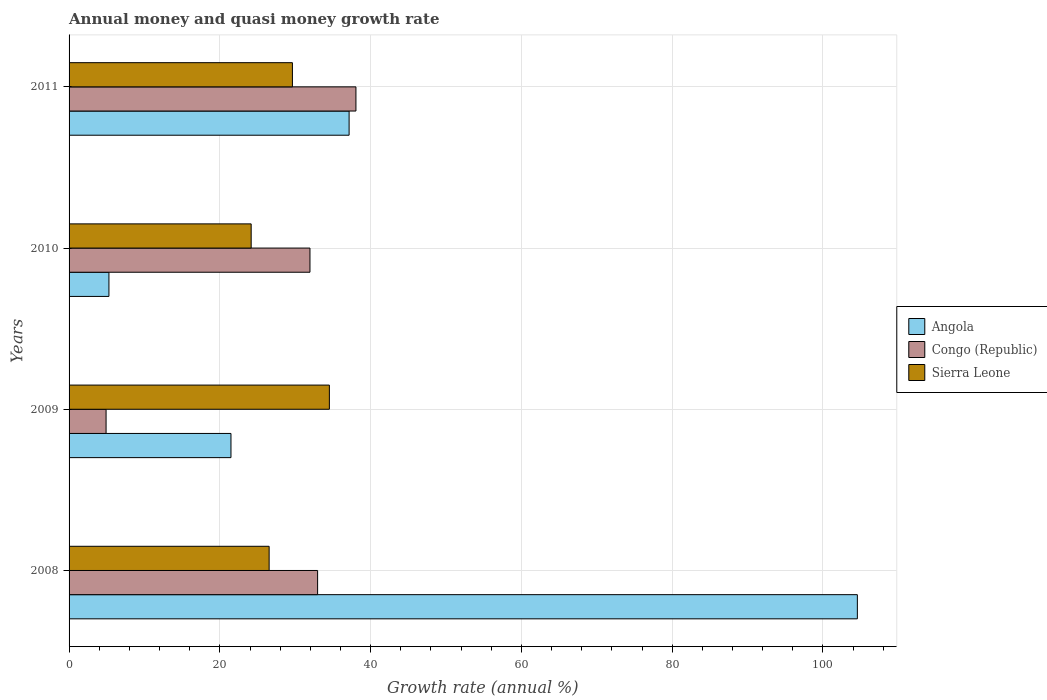Are the number of bars per tick equal to the number of legend labels?
Provide a short and direct response. Yes. How many bars are there on the 4th tick from the top?
Keep it short and to the point. 3. What is the growth rate in Angola in 2008?
Offer a terse response. 104.57. Across all years, what is the maximum growth rate in Congo (Republic)?
Your response must be concise. 38.05. Across all years, what is the minimum growth rate in Congo (Republic)?
Provide a short and direct response. 4.91. What is the total growth rate in Congo (Republic) in the graph?
Make the answer very short. 107.89. What is the difference between the growth rate in Angola in 2008 and that in 2010?
Offer a terse response. 99.28. What is the difference between the growth rate in Angola in 2010 and the growth rate in Sierra Leone in 2009?
Make the answer very short. -29.24. What is the average growth rate in Congo (Republic) per year?
Ensure brevity in your answer.  26.97. In the year 2009, what is the difference between the growth rate in Congo (Republic) and growth rate in Sierra Leone?
Keep it short and to the point. -29.62. In how many years, is the growth rate in Congo (Republic) greater than 72 %?
Offer a very short reply. 0. What is the ratio of the growth rate in Angola in 2010 to that in 2011?
Your answer should be compact. 0.14. Is the growth rate in Congo (Republic) in 2009 less than that in 2011?
Your response must be concise. Yes. What is the difference between the highest and the second highest growth rate in Congo (Republic)?
Offer a very short reply. 5.08. What is the difference between the highest and the lowest growth rate in Angola?
Your response must be concise. 99.28. In how many years, is the growth rate in Congo (Republic) greater than the average growth rate in Congo (Republic) taken over all years?
Offer a terse response. 3. What does the 3rd bar from the top in 2009 represents?
Keep it short and to the point. Angola. What does the 3rd bar from the bottom in 2011 represents?
Ensure brevity in your answer.  Sierra Leone. Is it the case that in every year, the sum of the growth rate in Congo (Republic) and growth rate in Sierra Leone is greater than the growth rate in Angola?
Keep it short and to the point. No. Are all the bars in the graph horizontal?
Keep it short and to the point. Yes. How many years are there in the graph?
Your answer should be very brief. 4. What is the difference between two consecutive major ticks on the X-axis?
Your response must be concise. 20. Are the values on the major ticks of X-axis written in scientific E-notation?
Provide a short and direct response. No. Does the graph contain any zero values?
Offer a terse response. No. Does the graph contain grids?
Offer a very short reply. Yes. Where does the legend appear in the graph?
Give a very brief answer. Center right. How many legend labels are there?
Offer a very short reply. 3. What is the title of the graph?
Your response must be concise. Annual money and quasi money growth rate. Does "Iran" appear as one of the legend labels in the graph?
Offer a terse response. No. What is the label or title of the X-axis?
Your answer should be compact. Growth rate (annual %). What is the label or title of the Y-axis?
Provide a succinct answer. Years. What is the Growth rate (annual %) of Angola in 2008?
Make the answer very short. 104.57. What is the Growth rate (annual %) in Congo (Republic) in 2008?
Your answer should be very brief. 32.97. What is the Growth rate (annual %) in Sierra Leone in 2008?
Your answer should be very brief. 26.54. What is the Growth rate (annual %) of Angola in 2009?
Offer a very short reply. 21.48. What is the Growth rate (annual %) of Congo (Republic) in 2009?
Provide a short and direct response. 4.91. What is the Growth rate (annual %) in Sierra Leone in 2009?
Provide a short and direct response. 34.53. What is the Growth rate (annual %) of Angola in 2010?
Your answer should be compact. 5.29. What is the Growth rate (annual %) in Congo (Republic) in 2010?
Give a very brief answer. 31.96. What is the Growth rate (annual %) in Sierra Leone in 2010?
Ensure brevity in your answer.  24.15. What is the Growth rate (annual %) of Angola in 2011?
Provide a succinct answer. 37.15. What is the Growth rate (annual %) in Congo (Republic) in 2011?
Ensure brevity in your answer.  38.05. What is the Growth rate (annual %) of Sierra Leone in 2011?
Give a very brief answer. 29.63. Across all years, what is the maximum Growth rate (annual %) of Angola?
Give a very brief answer. 104.57. Across all years, what is the maximum Growth rate (annual %) in Congo (Republic)?
Make the answer very short. 38.05. Across all years, what is the maximum Growth rate (annual %) in Sierra Leone?
Your answer should be compact. 34.53. Across all years, what is the minimum Growth rate (annual %) of Angola?
Provide a short and direct response. 5.29. Across all years, what is the minimum Growth rate (annual %) of Congo (Republic)?
Offer a terse response. 4.91. Across all years, what is the minimum Growth rate (annual %) of Sierra Leone?
Your answer should be compact. 24.15. What is the total Growth rate (annual %) in Angola in the graph?
Your answer should be very brief. 168.48. What is the total Growth rate (annual %) in Congo (Republic) in the graph?
Ensure brevity in your answer.  107.89. What is the total Growth rate (annual %) in Sierra Leone in the graph?
Provide a short and direct response. 114.85. What is the difference between the Growth rate (annual %) in Angola in 2008 and that in 2009?
Provide a succinct answer. 83.09. What is the difference between the Growth rate (annual %) of Congo (Republic) in 2008 and that in 2009?
Keep it short and to the point. 28.06. What is the difference between the Growth rate (annual %) of Sierra Leone in 2008 and that in 2009?
Give a very brief answer. -7.99. What is the difference between the Growth rate (annual %) of Angola in 2008 and that in 2010?
Your answer should be compact. 99.28. What is the difference between the Growth rate (annual %) of Congo (Republic) in 2008 and that in 2010?
Provide a succinct answer. 1.01. What is the difference between the Growth rate (annual %) of Sierra Leone in 2008 and that in 2010?
Offer a terse response. 2.38. What is the difference between the Growth rate (annual %) of Angola in 2008 and that in 2011?
Offer a very short reply. 67.42. What is the difference between the Growth rate (annual %) of Congo (Republic) in 2008 and that in 2011?
Provide a short and direct response. -5.08. What is the difference between the Growth rate (annual %) of Sierra Leone in 2008 and that in 2011?
Ensure brevity in your answer.  -3.09. What is the difference between the Growth rate (annual %) of Angola in 2009 and that in 2010?
Offer a very short reply. 16.19. What is the difference between the Growth rate (annual %) of Congo (Republic) in 2009 and that in 2010?
Your response must be concise. -27.05. What is the difference between the Growth rate (annual %) of Sierra Leone in 2009 and that in 2010?
Give a very brief answer. 10.37. What is the difference between the Growth rate (annual %) of Angola in 2009 and that in 2011?
Your answer should be compact. -15.67. What is the difference between the Growth rate (annual %) of Congo (Republic) in 2009 and that in 2011?
Give a very brief answer. -33.14. What is the difference between the Growth rate (annual %) of Sierra Leone in 2009 and that in 2011?
Your answer should be very brief. 4.9. What is the difference between the Growth rate (annual %) in Angola in 2010 and that in 2011?
Ensure brevity in your answer.  -31.86. What is the difference between the Growth rate (annual %) in Congo (Republic) in 2010 and that in 2011?
Your response must be concise. -6.1. What is the difference between the Growth rate (annual %) in Sierra Leone in 2010 and that in 2011?
Make the answer very short. -5.47. What is the difference between the Growth rate (annual %) in Angola in 2008 and the Growth rate (annual %) in Congo (Republic) in 2009?
Give a very brief answer. 99.66. What is the difference between the Growth rate (annual %) in Angola in 2008 and the Growth rate (annual %) in Sierra Leone in 2009?
Make the answer very short. 70.04. What is the difference between the Growth rate (annual %) of Congo (Republic) in 2008 and the Growth rate (annual %) of Sierra Leone in 2009?
Give a very brief answer. -1.56. What is the difference between the Growth rate (annual %) of Angola in 2008 and the Growth rate (annual %) of Congo (Republic) in 2010?
Your response must be concise. 72.61. What is the difference between the Growth rate (annual %) in Angola in 2008 and the Growth rate (annual %) in Sierra Leone in 2010?
Ensure brevity in your answer.  80.41. What is the difference between the Growth rate (annual %) in Congo (Republic) in 2008 and the Growth rate (annual %) in Sierra Leone in 2010?
Your answer should be very brief. 8.81. What is the difference between the Growth rate (annual %) in Angola in 2008 and the Growth rate (annual %) in Congo (Republic) in 2011?
Your response must be concise. 66.51. What is the difference between the Growth rate (annual %) of Angola in 2008 and the Growth rate (annual %) of Sierra Leone in 2011?
Provide a short and direct response. 74.94. What is the difference between the Growth rate (annual %) in Congo (Republic) in 2008 and the Growth rate (annual %) in Sierra Leone in 2011?
Provide a short and direct response. 3.34. What is the difference between the Growth rate (annual %) of Angola in 2009 and the Growth rate (annual %) of Congo (Republic) in 2010?
Ensure brevity in your answer.  -10.48. What is the difference between the Growth rate (annual %) of Angola in 2009 and the Growth rate (annual %) of Sierra Leone in 2010?
Keep it short and to the point. -2.68. What is the difference between the Growth rate (annual %) of Congo (Republic) in 2009 and the Growth rate (annual %) of Sierra Leone in 2010?
Offer a very short reply. -19.25. What is the difference between the Growth rate (annual %) of Angola in 2009 and the Growth rate (annual %) of Congo (Republic) in 2011?
Make the answer very short. -16.58. What is the difference between the Growth rate (annual %) in Angola in 2009 and the Growth rate (annual %) in Sierra Leone in 2011?
Provide a short and direct response. -8.15. What is the difference between the Growth rate (annual %) of Congo (Republic) in 2009 and the Growth rate (annual %) of Sierra Leone in 2011?
Offer a terse response. -24.72. What is the difference between the Growth rate (annual %) of Angola in 2010 and the Growth rate (annual %) of Congo (Republic) in 2011?
Provide a succinct answer. -32.76. What is the difference between the Growth rate (annual %) in Angola in 2010 and the Growth rate (annual %) in Sierra Leone in 2011?
Your answer should be very brief. -24.34. What is the difference between the Growth rate (annual %) in Congo (Republic) in 2010 and the Growth rate (annual %) in Sierra Leone in 2011?
Make the answer very short. 2.33. What is the average Growth rate (annual %) in Angola per year?
Offer a terse response. 42.12. What is the average Growth rate (annual %) of Congo (Republic) per year?
Make the answer very short. 26.97. What is the average Growth rate (annual %) in Sierra Leone per year?
Provide a short and direct response. 28.71. In the year 2008, what is the difference between the Growth rate (annual %) of Angola and Growth rate (annual %) of Congo (Republic)?
Offer a very short reply. 71.6. In the year 2008, what is the difference between the Growth rate (annual %) of Angola and Growth rate (annual %) of Sierra Leone?
Give a very brief answer. 78.03. In the year 2008, what is the difference between the Growth rate (annual %) of Congo (Republic) and Growth rate (annual %) of Sierra Leone?
Offer a very short reply. 6.43. In the year 2009, what is the difference between the Growth rate (annual %) of Angola and Growth rate (annual %) of Congo (Republic)?
Make the answer very short. 16.57. In the year 2009, what is the difference between the Growth rate (annual %) in Angola and Growth rate (annual %) in Sierra Leone?
Provide a succinct answer. -13.05. In the year 2009, what is the difference between the Growth rate (annual %) in Congo (Republic) and Growth rate (annual %) in Sierra Leone?
Provide a succinct answer. -29.62. In the year 2010, what is the difference between the Growth rate (annual %) in Angola and Growth rate (annual %) in Congo (Republic)?
Make the answer very short. -26.67. In the year 2010, what is the difference between the Growth rate (annual %) of Angola and Growth rate (annual %) of Sierra Leone?
Make the answer very short. -18.87. In the year 2010, what is the difference between the Growth rate (annual %) in Congo (Republic) and Growth rate (annual %) in Sierra Leone?
Your answer should be very brief. 7.8. In the year 2011, what is the difference between the Growth rate (annual %) in Angola and Growth rate (annual %) in Congo (Republic)?
Give a very brief answer. -0.91. In the year 2011, what is the difference between the Growth rate (annual %) of Angola and Growth rate (annual %) of Sierra Leone?
Your answer should be compact. 7.52. In the year 2011, what is the difference between the Growth rate (annual %) of Congo (Republic) and Growth rate (annual %) of Sierra Leone?
Give a very brief answer. 8.42. What is the ratio of the Growth rate (annual %) in Angola in 2008 to that in 2009?
Your answer should be compact. 4.87. What is the ratio of the Growth rate (annual %) of Congo (Republic) in 2008 to that in 2009?
Offer a terse response. 6.72. What is the ratio of the Growth rate (annual %) in Sierra Leone in 2008 to that in 2009?
Your answer should be compact. 0.77. What is the ratio of the Growth rate (annual %) in Angola in 2008 to that in 2010?
Your answer should be very brief. 19.77. What is the ratio of the Growth rate (annual %) of Congo (Republic) in 2008 to that in 2010?
Offer a terse response. 1.03. What is the ratio of the Growth rate (annual %) of Sierra Leone in 2008 to that in 2010?
Make the answer very short. 1.1. What is the ratio of the Growth rate (annual %) in Angola in 2008 to that in 2011?
Provide a short and direct response. 2.81. What is the ratio of the Growth rate (annual %) of Congo (Republic) in 2008 to that in 2011?
Provide a succinct answer. 0.87. What is the ratio of the Growth rate (annual %) of Sierra Leone in 2008 to that in 2011?
Provide a short and direct response. 0.9. What is the ratio of the Growth rate (annual %) of Angola in 2009 to that in 2010?
Your response must be concise. 4.06. What is the ratio of the Growth rate (annual %) of Congo (Republic) in 2009 to that in 2010?
Offer a very short reply. 0.15. What is the ratio of the Growth rate (annual %) of Sierra Leone in 2009 to that in 2010?
Provide a short and direct response. 1.43. What is the ratio of the Growth rate (annual %) of Angola in 2009 to that in 2011?
Give a very brief answer. 0.58. What is the ratio of the Growth rate (annual %) in Congo (Republic) in 2009 to that in 2011?
Keep it short and to the point. 0.13. What is the ratio of the Growth rate (annual %) in Sierra Leone in 2009 to that in 2011?
Your response must be concise. 1.17. What is the ratio of the Growth rate (annual %) in Angola in 2010 to that in 2011?
Make the answer very short. 0.14. What is the ratio of the Growth rate (annual %) of Congo (Republic) in 2010 to that in 2011?
Your answer should be compact. 0.84. What is the ratio of the Growth rate (annual %) in Sierra Leone in 2010 to that in 2011?
Keep it short and to the point. 0.82. What is the difference between the highest and the second highest Growth rate (annual %) of Angola?
Your response must be concise. 67.42. What is the difference between the highest and the second highest Growth rate (annual %) in Congo (Republic)?
Your answer should be very brief. 5.08. What is the difference between the highest and the second highest Growth rate (annual %) of Sierra Leone?
Your answer should be very brief. 4.9. What is the difference between the highest and the lowest Growth rate (annual %) in Angola?
Provide a succinct answer. 99.28. What is the difference between the highest and the lowest Growth rate (annual %) of Congo (Republic)?
Your answer should be very brief. 33.14. What is the difference between the highest and the lowest Growth rate (annual %) of Sierra Leone?
Your answer should be very brief. 10.37. 